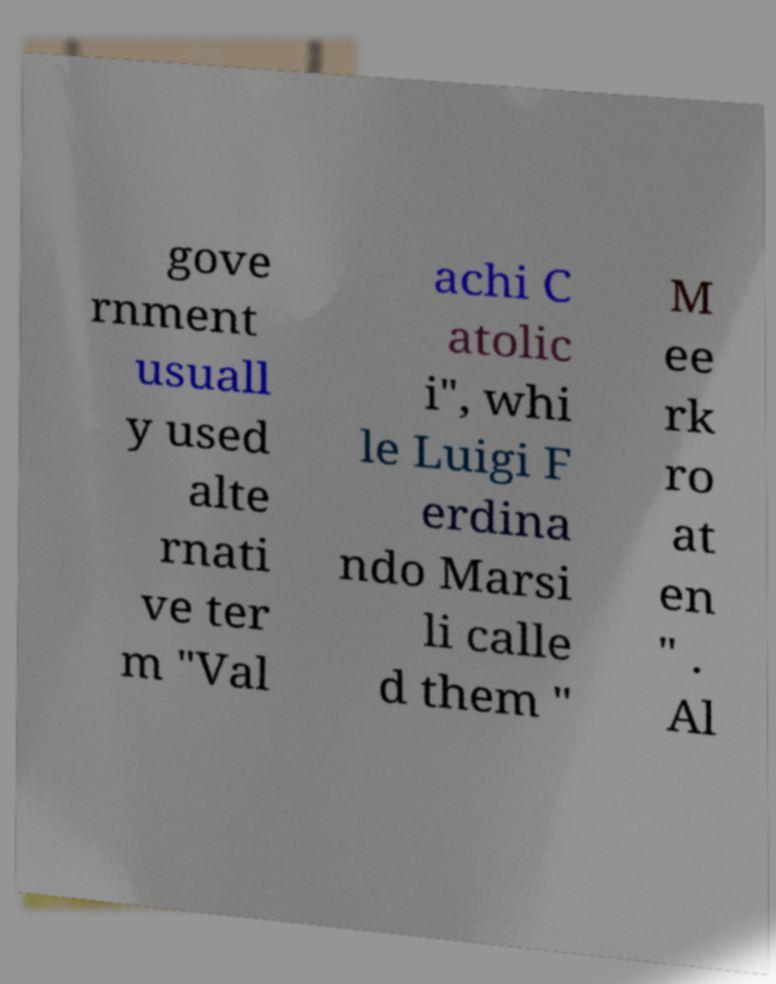Please read and relay the text visible in this image. What does it say? gove rnment usuall y used alte rnati ve ter m "Val achi C atolic i", whi le Luigi F erdina ndo Marsi li calle d them " M ee rk ro at en " . Al 